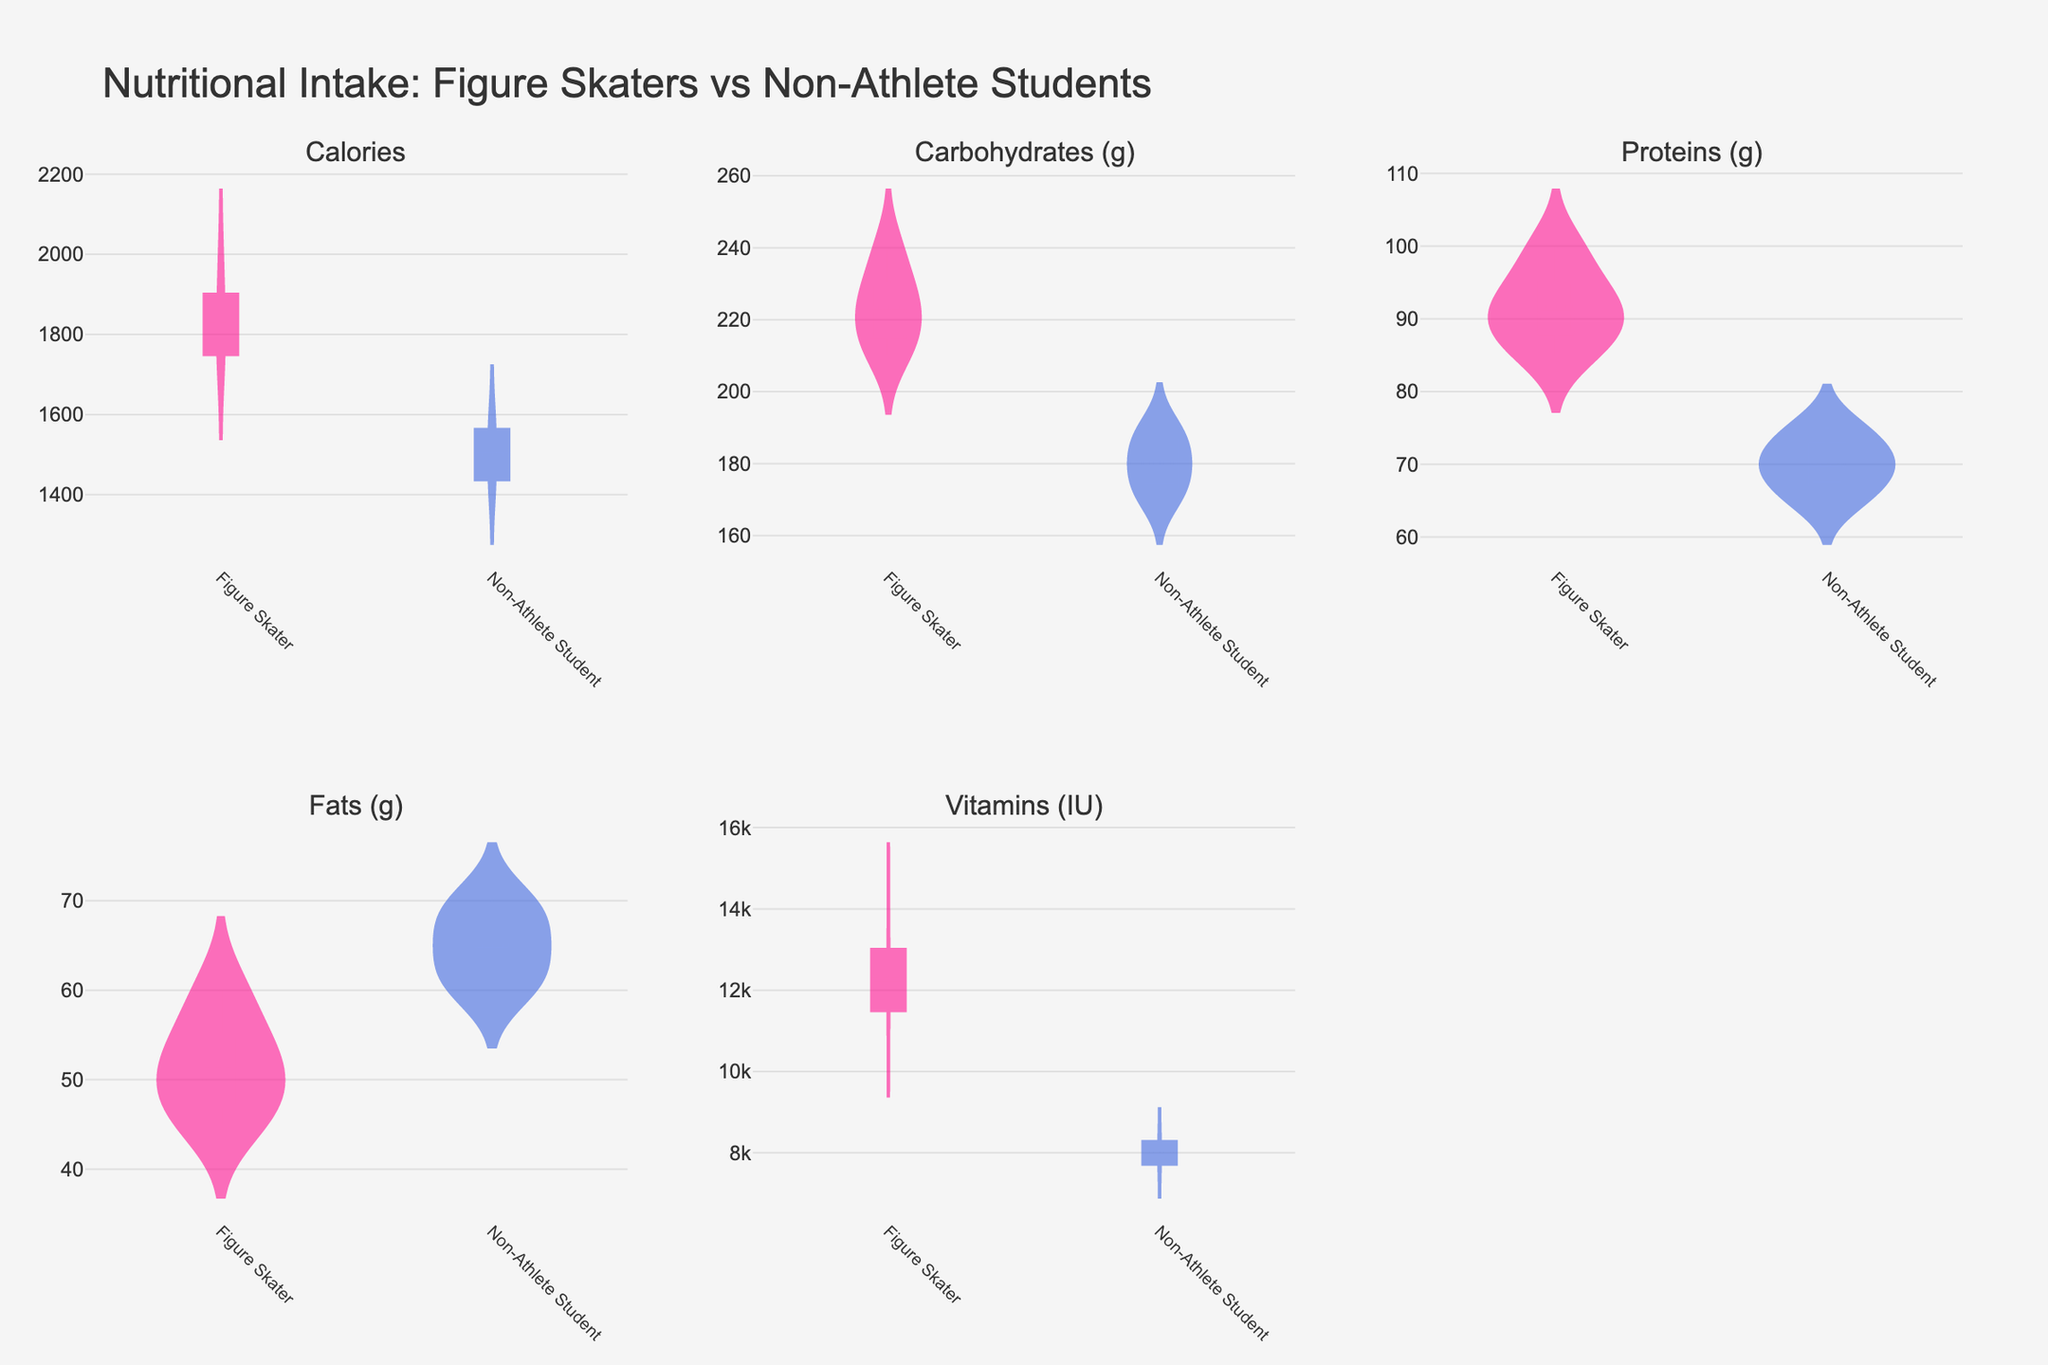What is the title of the plot? The title of the plot is usually placed at the top of the figure. In this case, it is clearly stated at the top of the plot.
Answer: Nutritional Intake: Figure Skaters vs Non-Athlete Students How many subplots are there in total? Count the number of distinct plots within the figure. This figure has multiple subplots for different nutritional components.
Answer: 5 Which category has higher calorie intake overall? Look at the violin plots for calories of both Figure Skaters and Non-Athlete Students and compare their distributions. The calories for Figure Skaters range higher than those for Non-Athlete Students.
Answer: Figure Skater In which nutrient category do Non-Athlete Students have the highest variance? Identify the nutrient category where the Non-Athlete Students’ violin plot is the widest, which indicates the highest variance.
Answer: Fats (g) What is the mean carbohydrate intake for Figure Skaters? The violin plot for Carbohydrates (g) shows a mean line. Look at the midpoint of the mean line for the Figure Skaters.
Answer: 223 g How do the protein intakes of Figure Skaters and Non-Athlete Students compare? Examine the violin plots for Proteins (g). Figure Skaters have higher central tendency values (mean and median) than Non-Athlete Students.
Answer: Figure Skaters have higher protein intake Are the vitamin intake levels higher for Figure Skaters or Non-Athlete Students? Compare the violin plots for Vitamins (IU). Figure Skaters have visibly higher central values on the plot.
Answer: Figure Skaters Is the average fat intake greater in Non-Athlete Students or Figure Skaters? Compare the mean lines within the Fats (g) violin plots. Non-Athlete Students have a higher average fat intake compared to Figure Skaters.
Answer: Non-Athlete Students What is the median calorie intake for Non-Athlete Students? The median is represented by the central line in the violin plot for Calories for the Non-Athlete Students' category.
Answer: 1500 calories Which nutrient shows the largest difference in intake between Figure Skaters and Non-Athlete Students? Compare the differences in the distributions of each nutrient between the two categories. Vitamins (IU) shows the largest visible difference.
Answer: Vitamins (IU) 